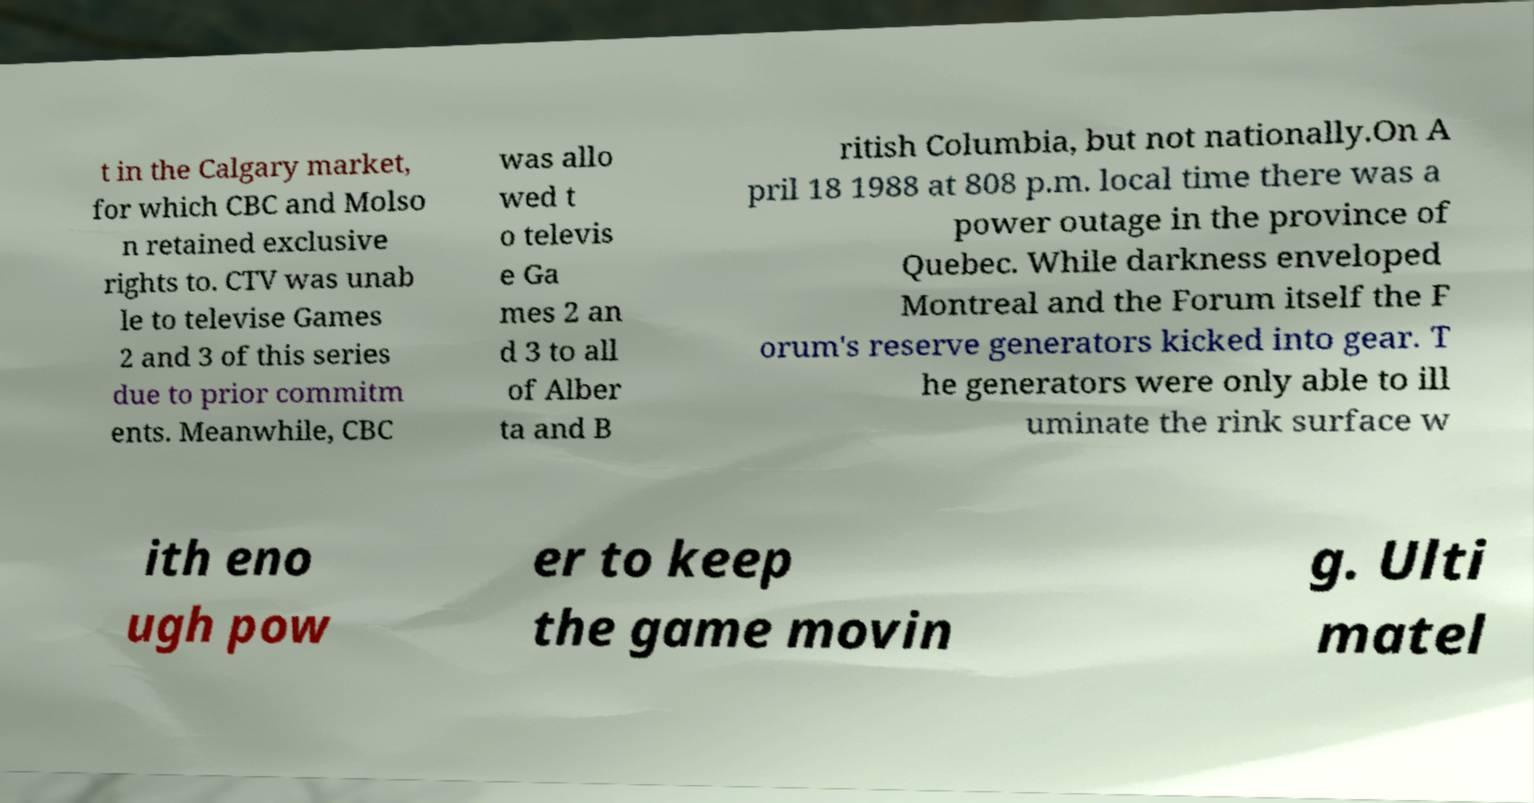Can you read and provide the text displayed in the image?This photo seems to have some interesting text. Can you extract and type it out for me? t in the Calgary market, for which CBC and Molso n retained exclusive rights to. CTV was unab le to televise Games 2 and 3 of this series due to prior commitm ents. Meanwhile, CBC was allo wed t o televis e Ga mes 2 an d 3 to all of Alber ta and B ritish Columbia, but not nationally.On A pril 18 1988 at 808 p.m. local time there was a power outage in the province of Quebec. While darkness enveloped Montreal and the Forum itself the F orum's reserve generators kicked into gear. T he generators were only able to ill uminate the rink surface w ith eno ugh pow er to keep the game movin g. Ulti matel 